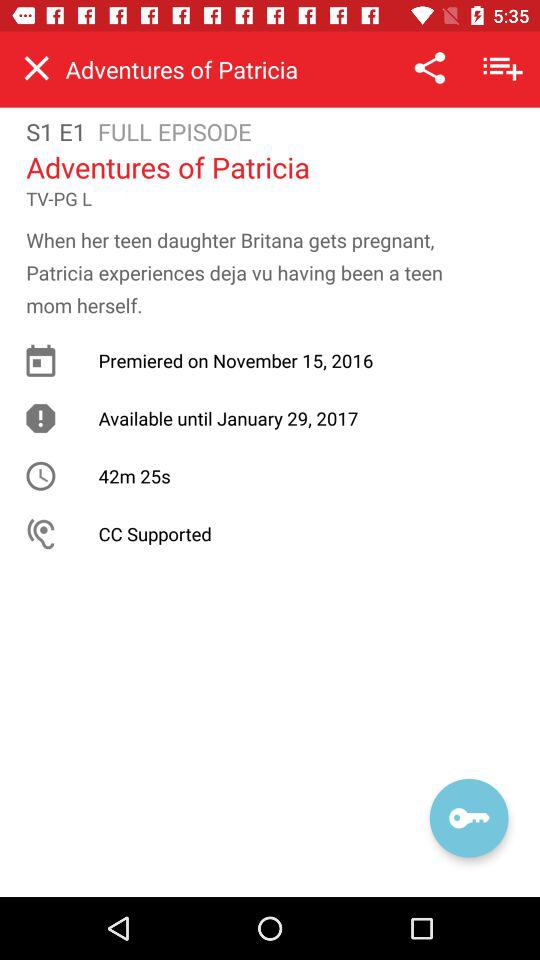At what time did "Adventures of Patricia" premier?
When the provided information is insufficient, respond with <no answer>. <no answer> 